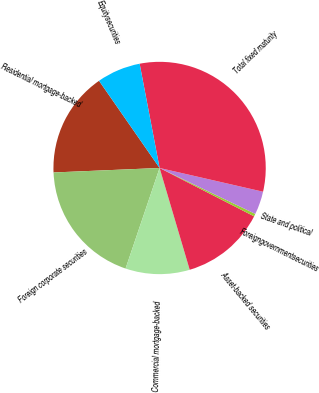Convert chart to OTSL. <chart><loc_0><loc_0><loc_500><loc_500><pie_chart><fcel>Residential mortgage-backed<fcel>Foreign corporate securities<fcel>Commercial mortgage-backed<fcel>Asset-backed securities<fcel>Foreigngovernmentsecurities<fcel>State and political<fcel>Total fixed maturity<fcel>Equitysecurities<nl><fcel>16.01%<fcel>19.13%<fcel>9.77%<fcel>12.89%<fcel>0.41%<fcel>3.53%<fcel>31.6%<fcel>6.65%<nl></chart> 